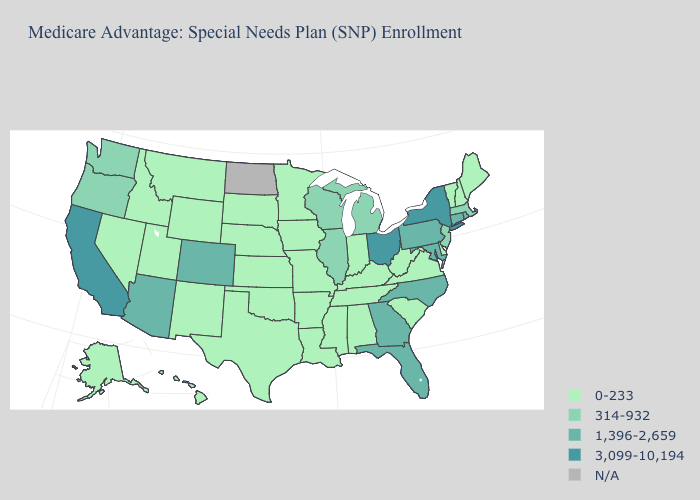How many symbols are there in the legend?
Answer briefly. 5. Name the states that have a value in the range 314-932?
Write a very short answer. Illinois, Massachusetts, Michigan, New Jersey, Oregon, Washington, Wisconsin. What is the value of Wisconsin?
Concise answer only. 314-932. What is the lowest value in states that border Nebraska?
Give a very brief answer. 0-233. Which states have the highest value in the USA?
Concise answer only. California, New York, Ohio. Does the first symbol in the legend represent the smallest category?
Answer briefly. Yes. What is the value of Ohio?
Answer briefly. 3,099-10,194. Which states hav the highest value in the MidWest?
Short answer required. Ohio. Which states have the lowest value in the USA?
Give a very brief answer. Alaska, Alabama, Arkansas, Delaware, Hawaii, Iowa, Idaho, Indiana, Kansas, Kentucky, Louisiana, Maine, Minnesota, Missouri, Mississippi, Montana, Nebraska, New Hampshire, New Mexico, Nevada, Oklahoma, South Carolina, South Dakota, Tennessee, Texas, Utah, Virginia, Vermont, West Virginia, Wyoming. Among the states that border Maine , which have the highest value?
Be succinct. New Hampshire. What is the highest value in the USA?
Concise answer only. 3,099-10,194. What is the highest value in the USA?
Keep it brief. 3,099-10,194. Does New York have the highest value in the Northeast?
Write a very short answer. Yes. Among the states that border Indiana , does Illinois have the highest value?
Keep it brief. No. 